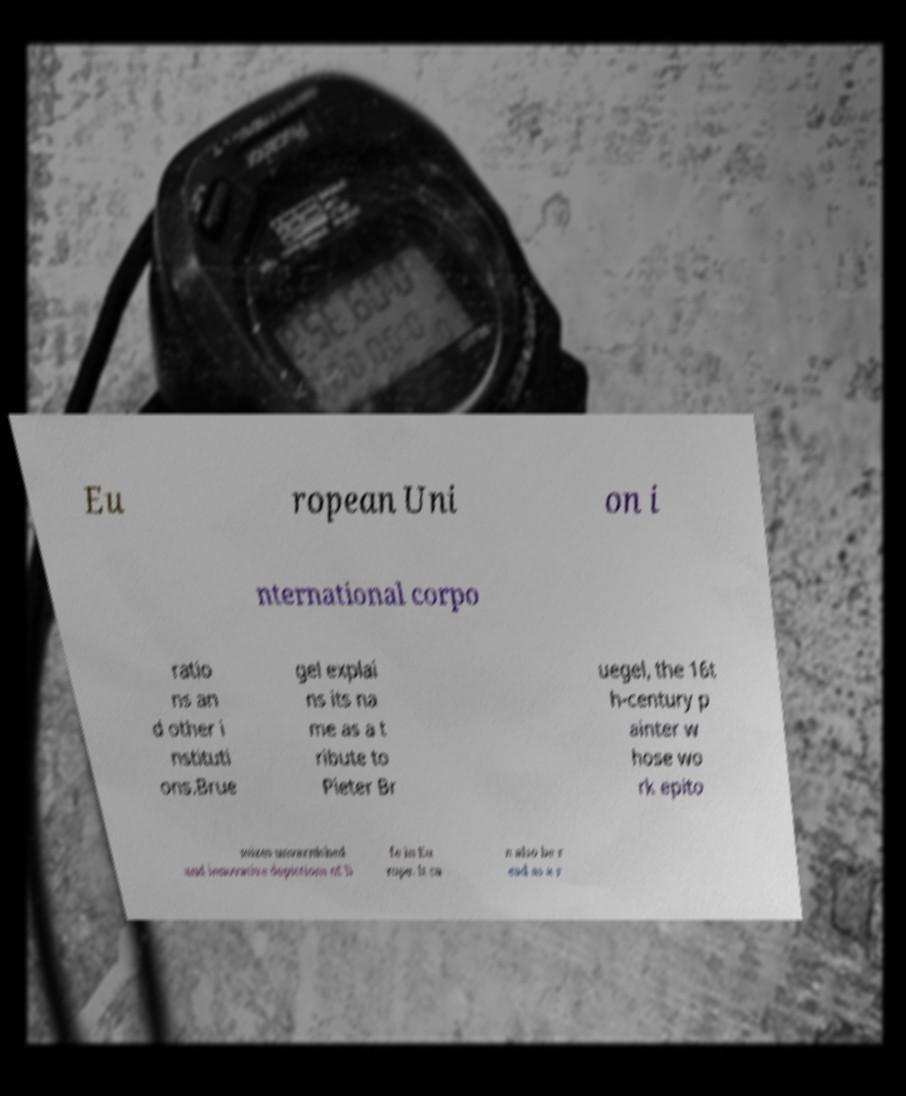Please identify and transcribe the text found in this image. Eu ropean Uni on i nternational corpo ratio ns an d other i nstituti ons.Brue gel explai ns its na me as a t ribute to Pieter Br uegel, the 16t h-century p ainter w hose wo rk epito mizes unvarnished and innovative depictions of li fe in Eu rope. It ca n also be r ead as a r 